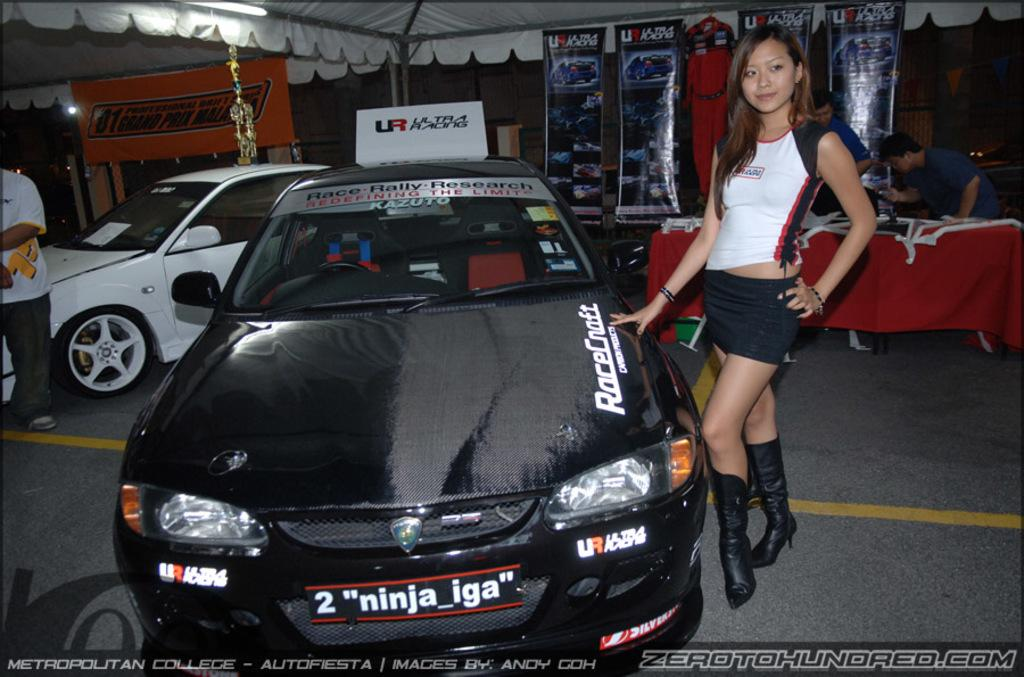Who is present in the image? There is a lady in the image. What is the lady doing in the image? The lady is standing beside a car. Can you describe the car in the image? There is writing on the car. Are there any other people in the image? Yes, there are other people in the image. How many cars are visible in the image? There is at least one car in the image. What else can be seen in the image? There is a table and posters in the image. What type of chess pieces can be seen on the table in the image? There is no chess set or pieces present on the table in the image. 